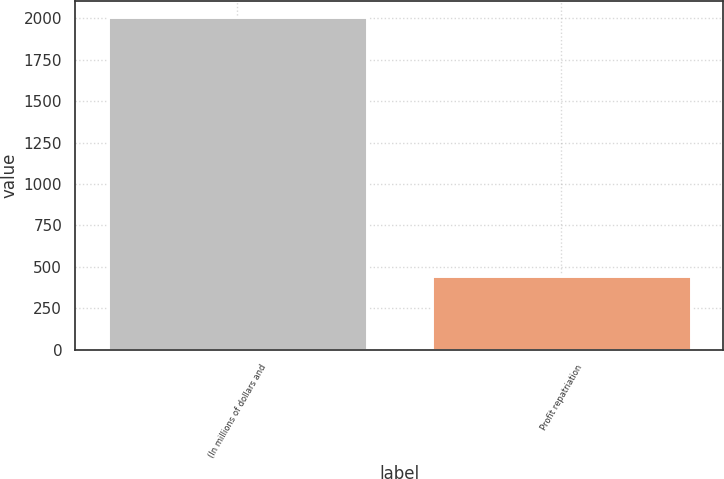<chart> <loc_0><loc_0><loc_500><loc_500><bar_chart><fcel>(In millions of dollars and<fcel>Profit repatriation<nl><fcel>2006<fcel>442<nl></chart> 